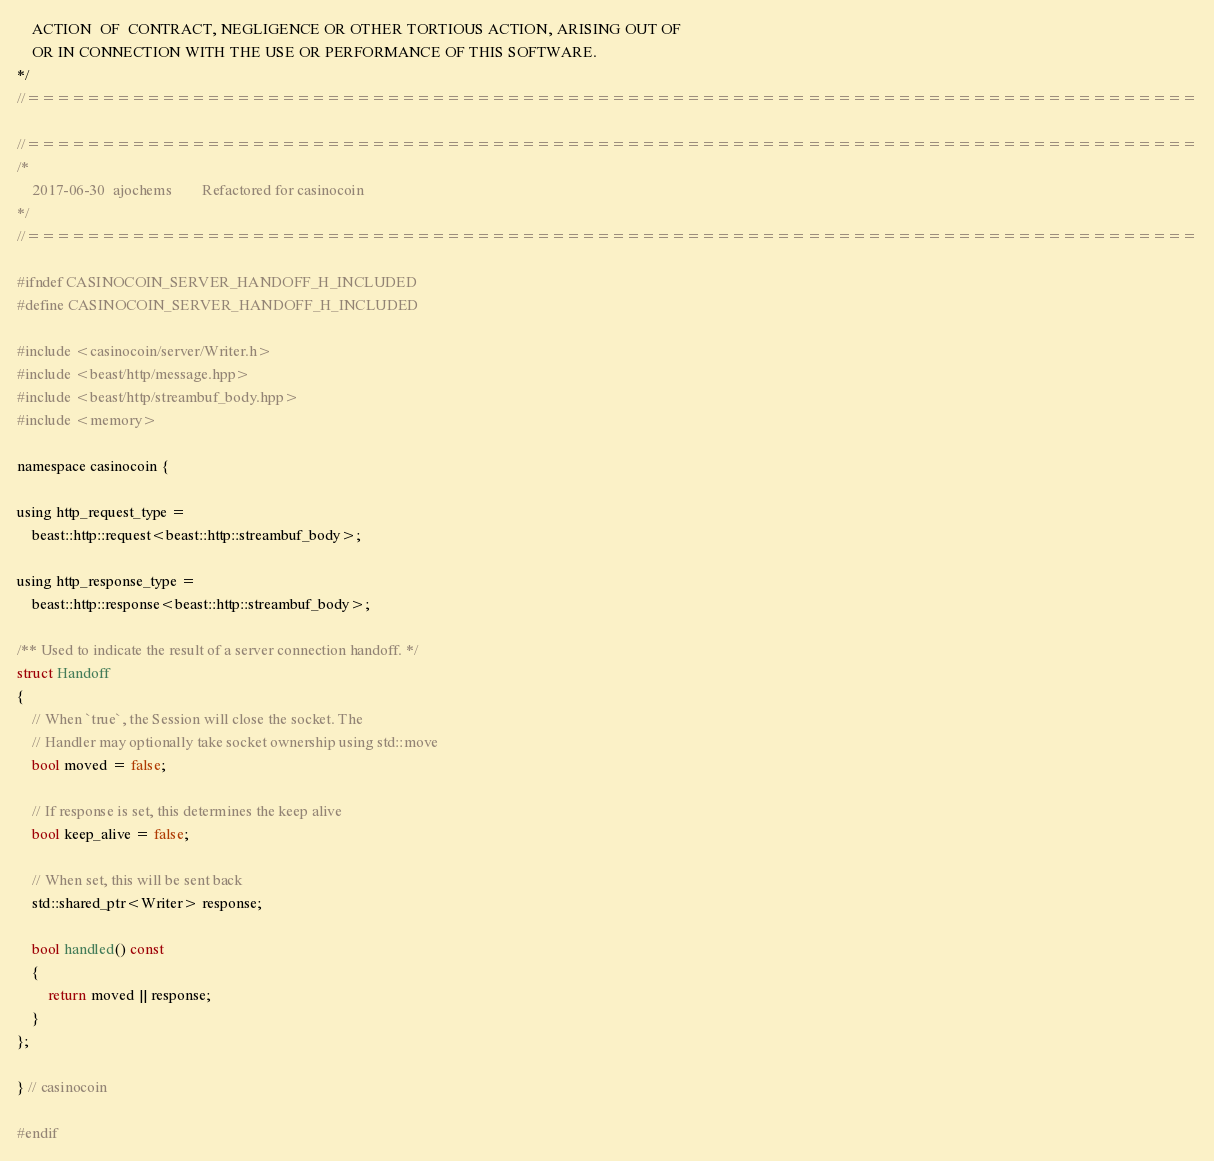Convert code to text. <code><loc_0><loc_0><loc_500><loc_500><_C_>    ACTION  OF  CONTRACT, NEGLIGENCE OR OTHER TORTIOUS ACTION, ARISING OUT OF
    OR IN CONNECTION WITH THE USE OR PERFORMANCE OF THIS SOFTWARE.
*/
//==============================================================================

//==============================================================================
/*
    2017-06-30  ajochems        Refactored for casinocoin
*/
//==============================================================================

#ifndef CASINOCOIN_SERVER_HANDOFF_H_INCLUDED
#define CASINOCOIN_SERVER_HANDOFF_H_INCLUDED

#include <casinocoin/server/Writer.h>
#include <beast/http/message.hpp>
#include <beast/http/streambuf_body.hpp>
#include <memory>

namespace casinocoin {

using http_request_type =
    beast::http::request<beast::http::streambuf_body>;

using http_response_type =
    beast::http::response<beast::http::streambuf_body>;

/** Used to indicate the result of a server connection handoff. */
struct Handoff
{
    // When `true`, the Session will close the socket. The
    // Handler may optionally take socket ownership using std::move
    bool moved = false;

    // If response is set, this determines the keep alive
    bool keep_alive = false;

    // When set, this will be sent back
    std::shared_ptr<Writer> response;

    bool handled() const
    {
        return moved || response;
    }
};

} // casinocoin

#endif
</code> 